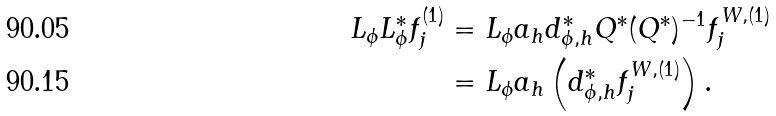<formula> <loc_0><loc_0><loc_500><loc_500>L _ { \phi } L _ { \phi } ^ { * } f _ { j } ^ { ( 1 ) } & = L _ { \phi } a _ { h } d _ { \phi , h } ^ { * } Q ^ { * } ( Q ^ { * } ) ^ { - 1 } f _ { j } ^ { W , ( 1 ) } \\ & = L _ { \phi } a _ { h } \left ( d _ { \phi , h } ^ { * } f _ { j } ^ { W , ( 1 ) } \right ) .</formula> 